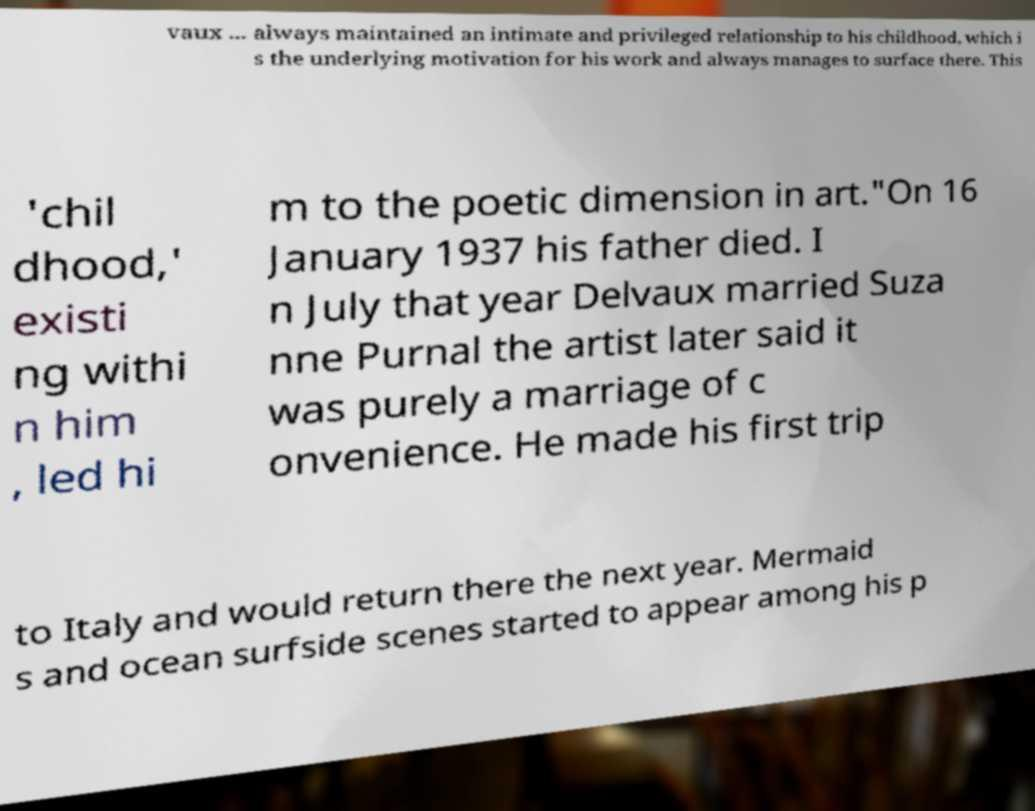Could you extract and type out the text from this image? vaux ... always maintained an intimate and privileged relationship to his childhood, which i s the underlying motivation for his work and always manages to surface there. This 'chil dhood,' existi ng withi n him , led hi m to the poetic dimension in art."On 16 January 1937 his father died. I n July that year Delvaux married Suza nne Purnal the artist later said it was purely a marriage of c onvenience. He made his first trip to Italy and would return there the next year. Mermaid s and ocean surfside scenes started to appear among his p 